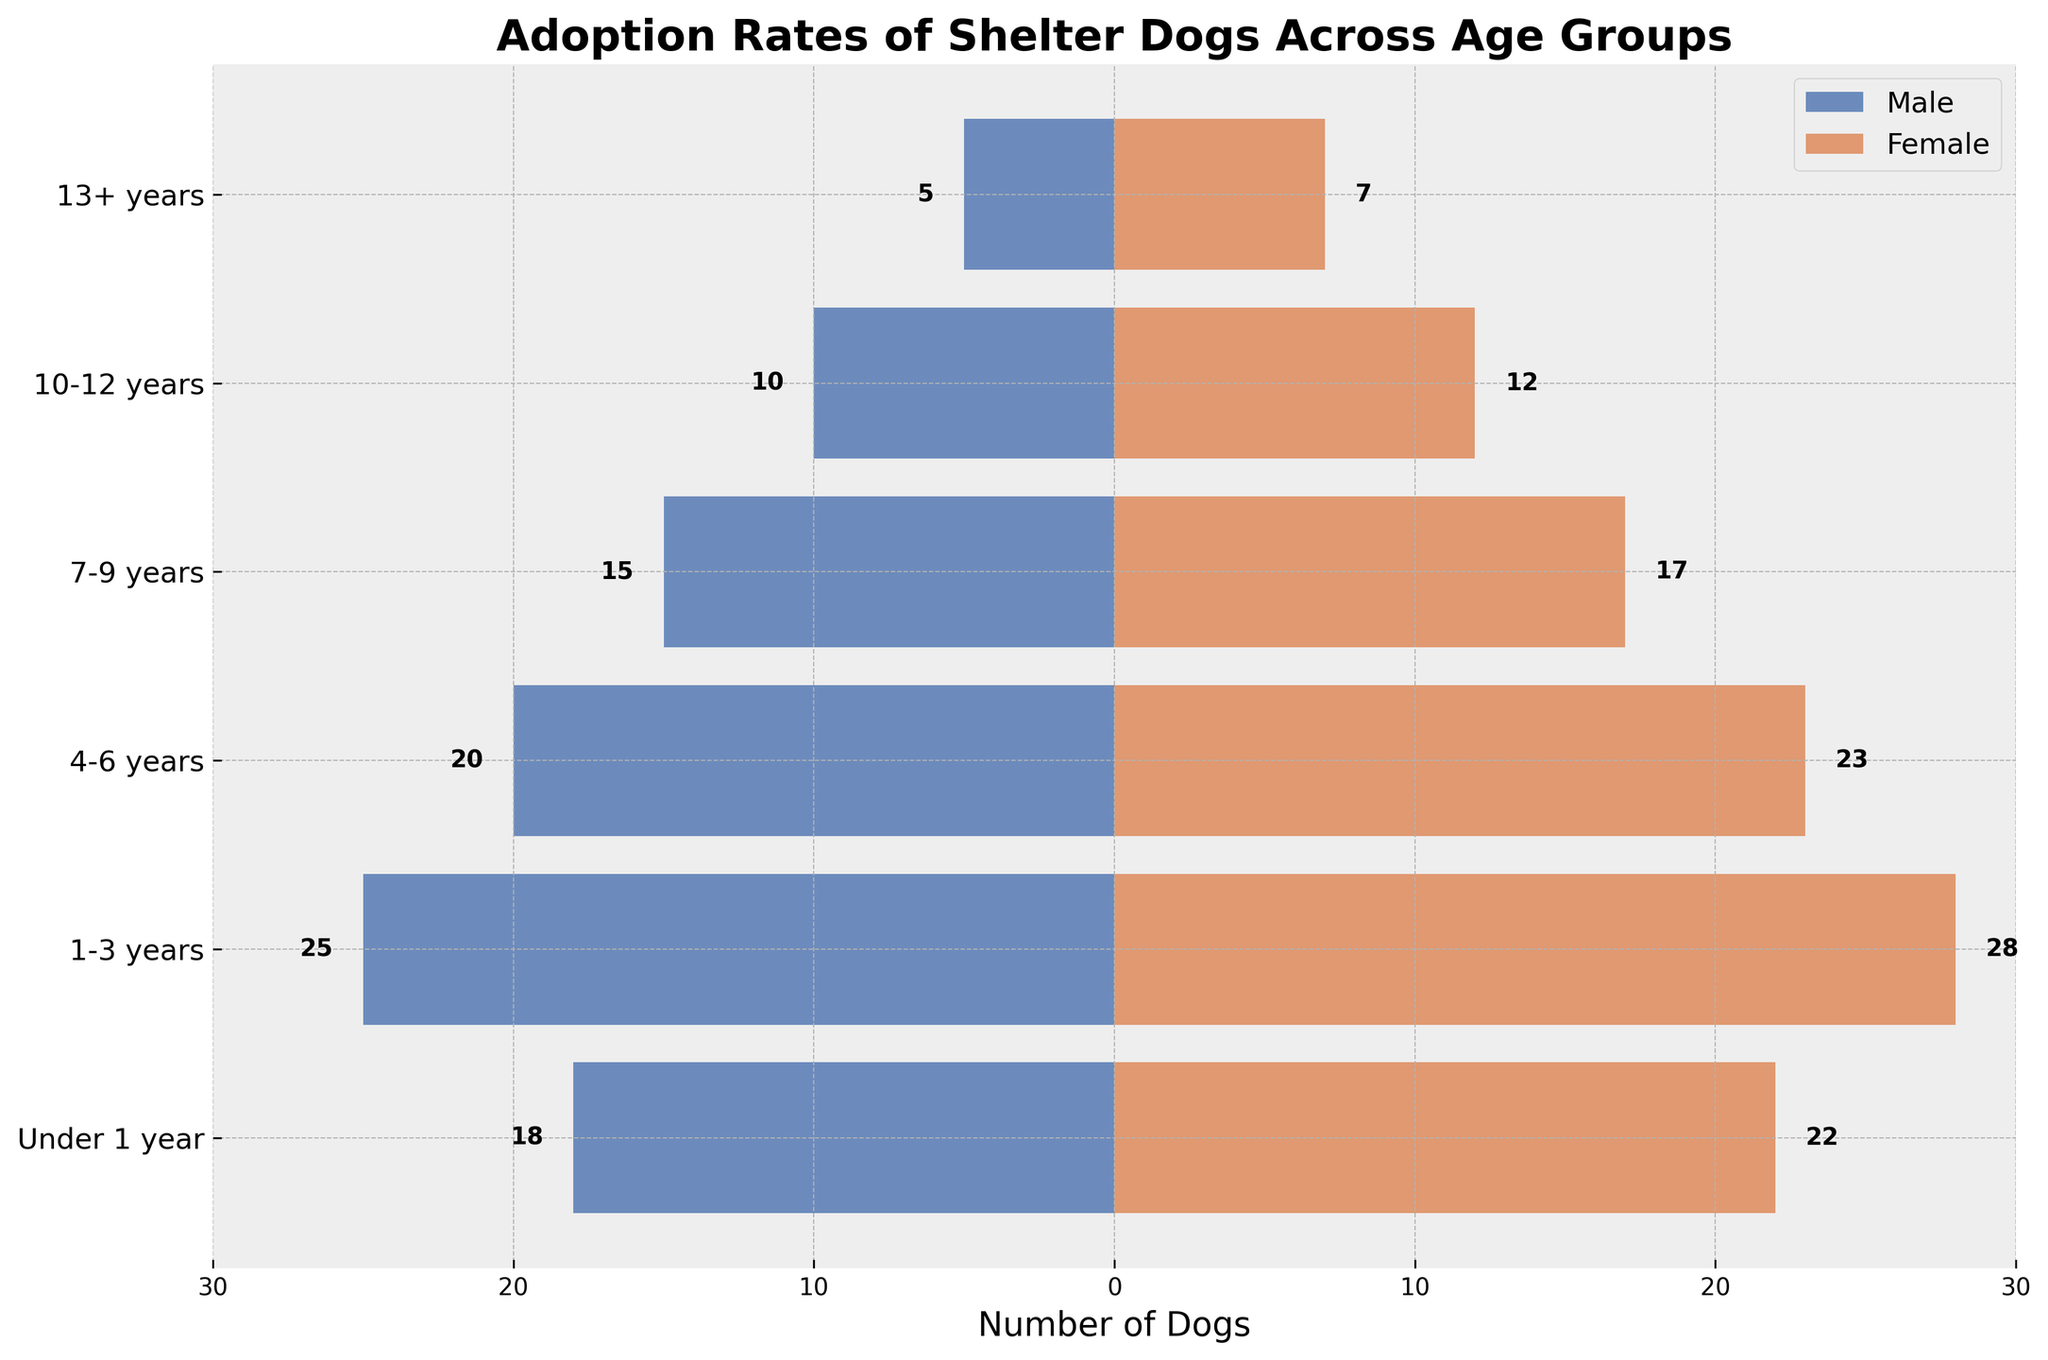What is the title of the figure? The title of the figure is usually displayed at the top and is bolded for emphasis. In this case, it states the main focus of the plot.
Answer: Adoption Rates of Shelter Dogs Across Age Groups Which age group has the highest number of adopted female dogs? By visually inspecting the lengths of the bars on the female side, we can see which bar extends the furthest to the right. The "1-3 years" age group has the longest bar.
Answer: 1-3 years Which age group has the lowest number of adopted male dogs? Looking at the lengths of the bars on the male side, the "13+ years" age group has the shortest bar, indicating the lowest number.
Answer: 13+ years How many more female dogs than male dogs were adopted in the "Under 1 year" age group? Subtract the number of male dogs (18) from the number of female dogs (22) in the "Under 1 year" age group.
Answer: 4 What is the total number of dogs adopted in the "4-6 years" age group? Add the number of male dogs (20) and female dogs (23) in this age group to get the total number.
Answer: 43 How many dogs were adopted in the "10-12 years" age group in total? Add the numbers of male (10) and female (12) dogs in this age group.
Answer: 22 Which age group has a more balanced adoption rate between male and female dogs? By comparing the lengths of bars for both males and females in each age group, the "Under 1 year" age group has nearly equal lengths, indicating a more balanced adoption rate.
Answer: Under 1 year How does the number of adopted female dogs in the "7-9 years" age group compare to the number in the "4-6 years" age group? The female bar for the "4-6 years" extends further to the right (23) than the female bar for the "7-9 years" (17). So, fewer female dogs were adopted in the "7-9 years".
Answer: Fewer in 7-9 years What is the average number of adopted male dogs across all age groups? Sum all the values for male dogs (18 + 25 + 20 + 15 + 10 + 5 = 93) and divide by the number of age groups (6).
Answer: 15.5 In which age group is the discrepancy between the number of adopted male and female dogs the largest? Calculate the difference between female and male numbers for all age groups. The largest difference (3) is in the "1-3 years" (28 - 25).
Answer: 1-3 years 